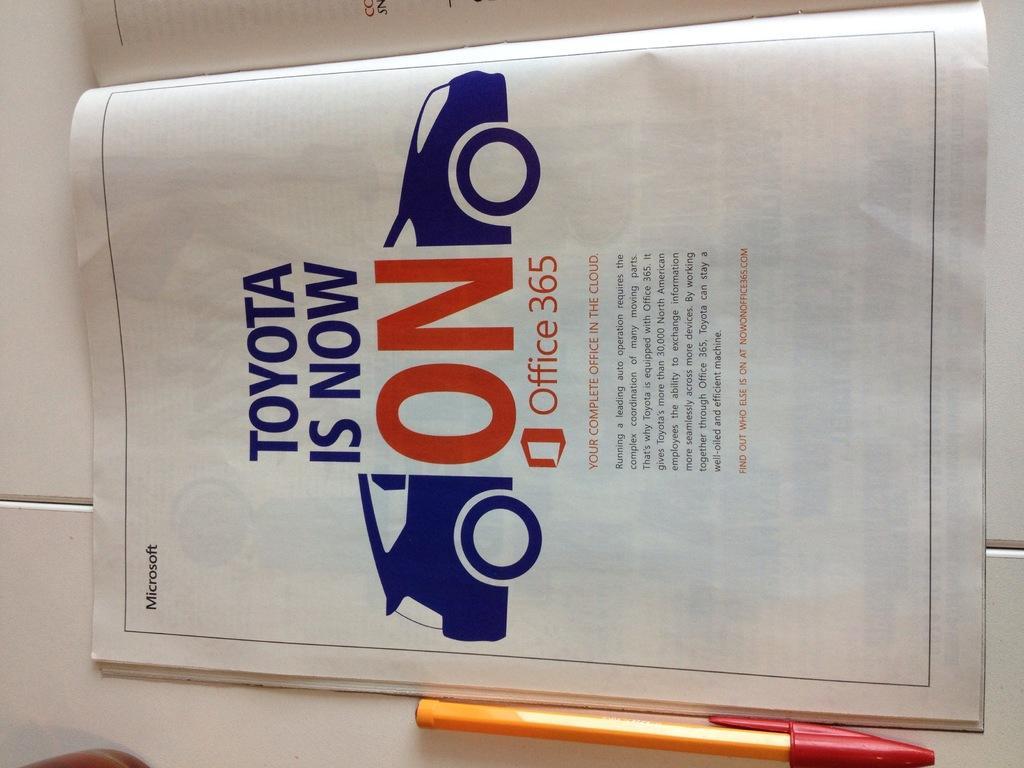How would you summarize this image in a sentence or two? In this picture we can see a book, pen and these two are placed on the white surface. 